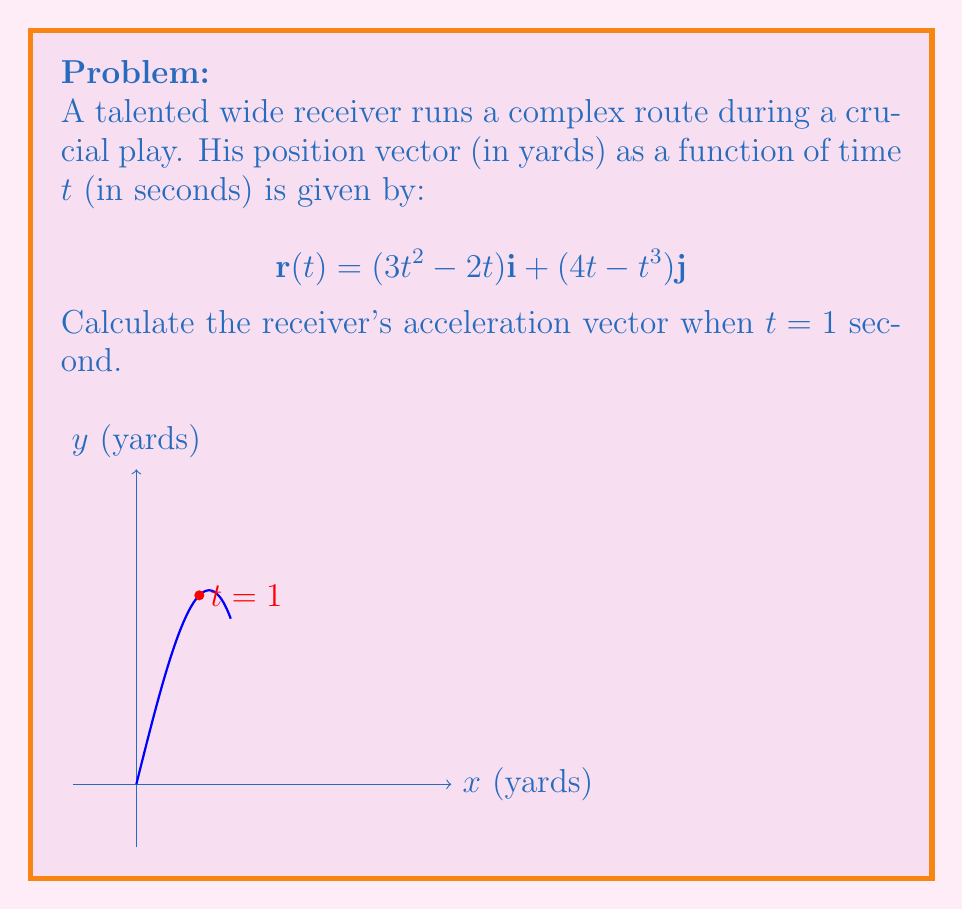Can you solve this math problem? To find the acceleration vector, we need to differentiate the position vector twice with respect to time:

1) First, let's find the velocity vector by differentiating $\mathbf{r}(t)$:

   $$\mathbf{v}(t) = \frac{d}{dt}\mathbf{r}(t) = (6t - 2)\mathbf{i} + (4 - 3t^2)\mathbf{j}$$

2) Now, we differentiate the velocity vector to get the acceleration vector:

   $$\mathbf{a}(t) = \frac{d}{dt}\mathbf{v}(t) = 6\mathbf{i} - 6t\mathbf{j}$$

3) To find the acceleration at t = 1 second, we substitute t = 1 into $\mathbf{a}(t)$:

   $$\mathbf{a}(1) = 6\mathbf{i} - 6(1)\mathbf{j} = 6\mathbf{i} - 6\mathbf{j}$$

Therefore, the acceleration vector when t = 1 second is $6\mathbf{i} - 6\mathbf{j}$ yards/s².
Answer: $6\mathbf{i} - 6\mathbf{j}$ yards/s² 